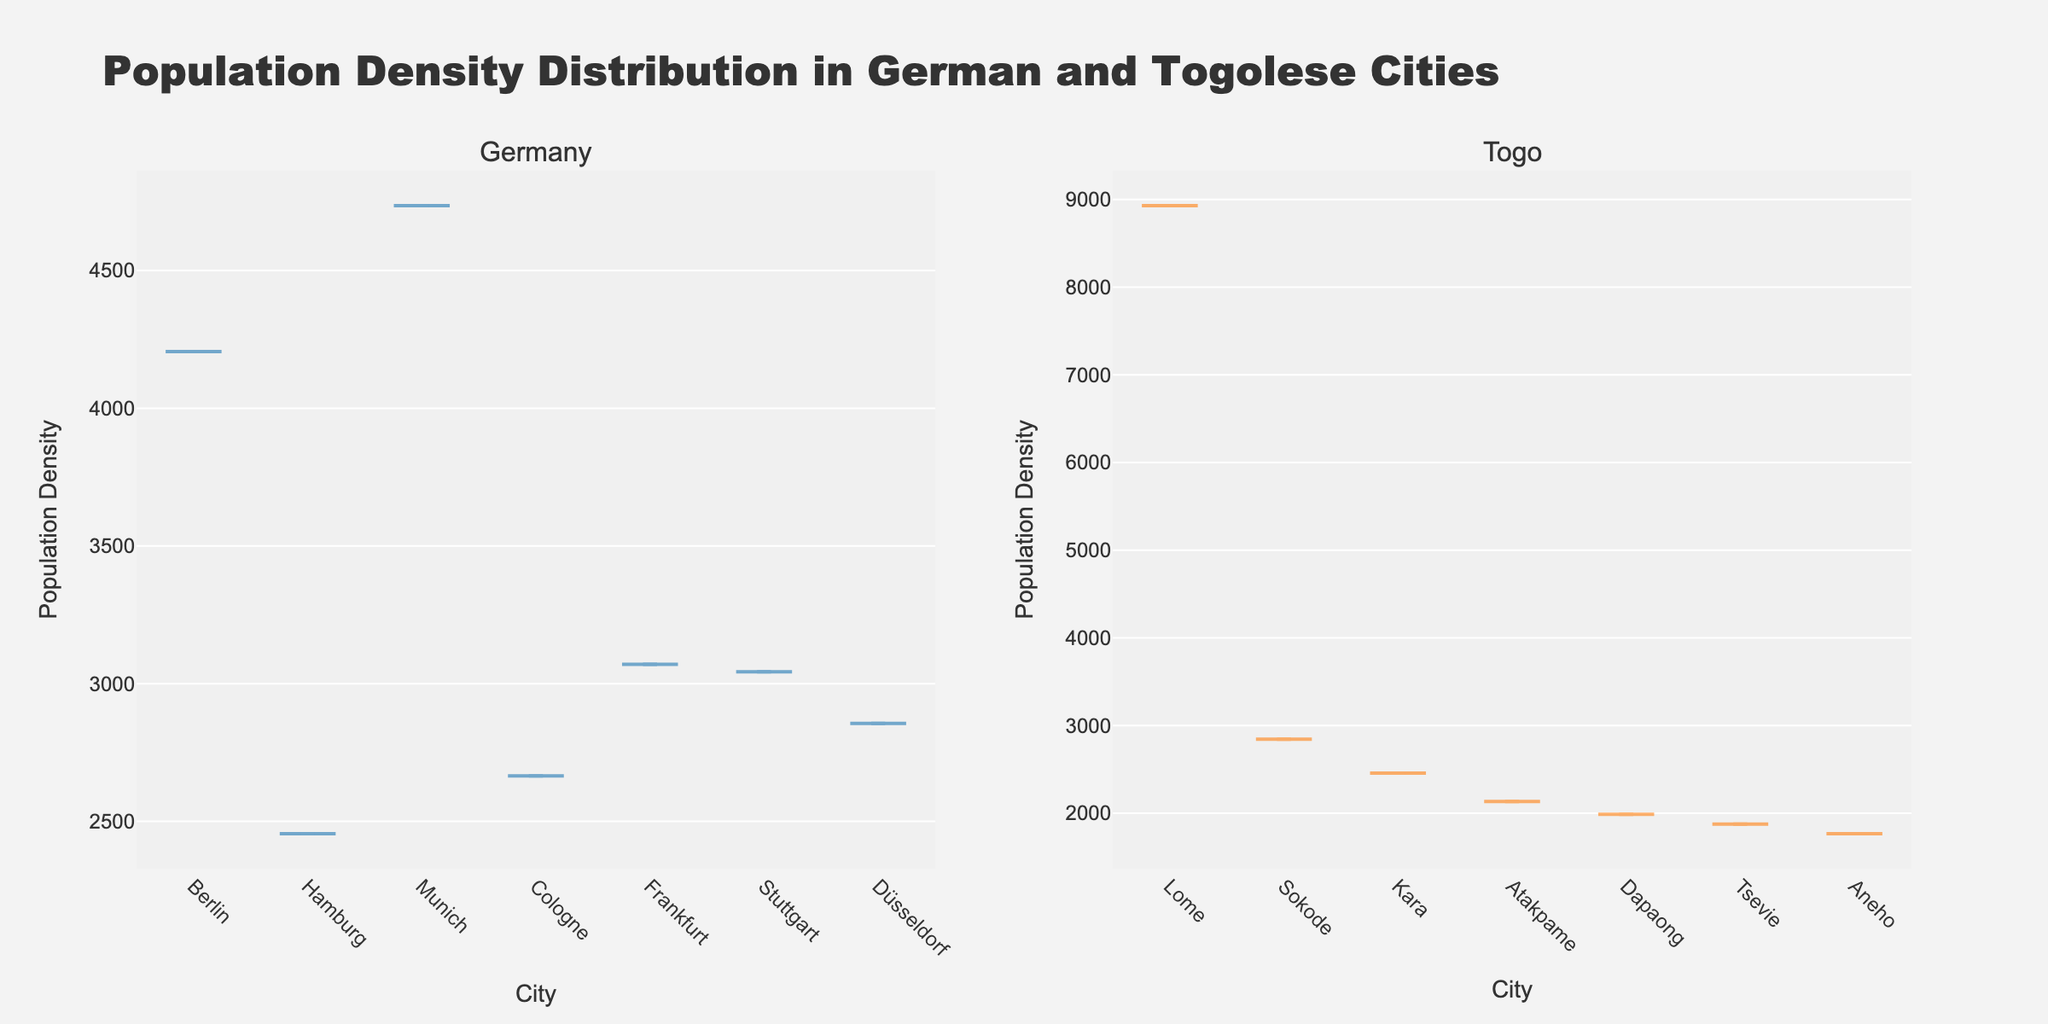Which country has a city with the highest population density? By comparing the top values of the population density in the plots, Lome in Togo has the highest density at 8931.
Answer: Togo Which city in Togo has the lowest population density in the figure? By looking at the density values plotted, Aneho has the lowest population density of 1765.
Answer: Aneho Is there any city in Germany with a higher population density than Lome in Togo? Comparing the highest values in both graphs, no city in Germany has a density that surpasses Lome's 8931 in Togo.
Answer: No What is the average population density of German cities in the figure? The cities in Germany have densities 4206, 2455, 4736, 2665, 3070, 3043, 2856. Summing them: 4206 + 2455 + 4736 + 2665 + 3070 + 3043 + 2856 = 23031, and the average is 23031 / 7 ≈ 3289.
Answer: 3289 How does the median population density of Togo's cities compare to Germany's? To find the medians, order the densities of Togo (8931, 2845, 2456, 2134, 1987, 1876, 1765), median is 2134. For Germany (4206, 2455, 4736, 2665, 3070, 3043, 2856), median is 3070.
Answer: Lower Which cities have population densities close to 3000? Analyzing both plots, Frankfurt (Germany) has 3070, Stuttgart (Germany) has 3043, Dusseldorf (Germany) has 2856, and Sokode (Togo) has 2845.
Answer: Frankfurt, Stuttgart, Dusseldorf, Sokode Are there more cities with population densities above 2500 in Germany or Togo? Counting the cities with densities above 2500: Germany has Berlin, Munich, Cologne, Frankfurt, Stuttgart, Dusseldorf, while Togo has only Lome and Sokode.
Answer: Germany Which city has a higher population density, Sokode in Togo or Cologne in Germany? By comparing their values, Sokode has 2845 while Cologne has 2665.
Answer: Sokode What observation can be made about the range of population densities in Togo compared to Germany? The range for Togo is from 1765 to 8931 (7166), and for Germany from 2455 to 4736 (2281).
Answer: Togo has a larger range 